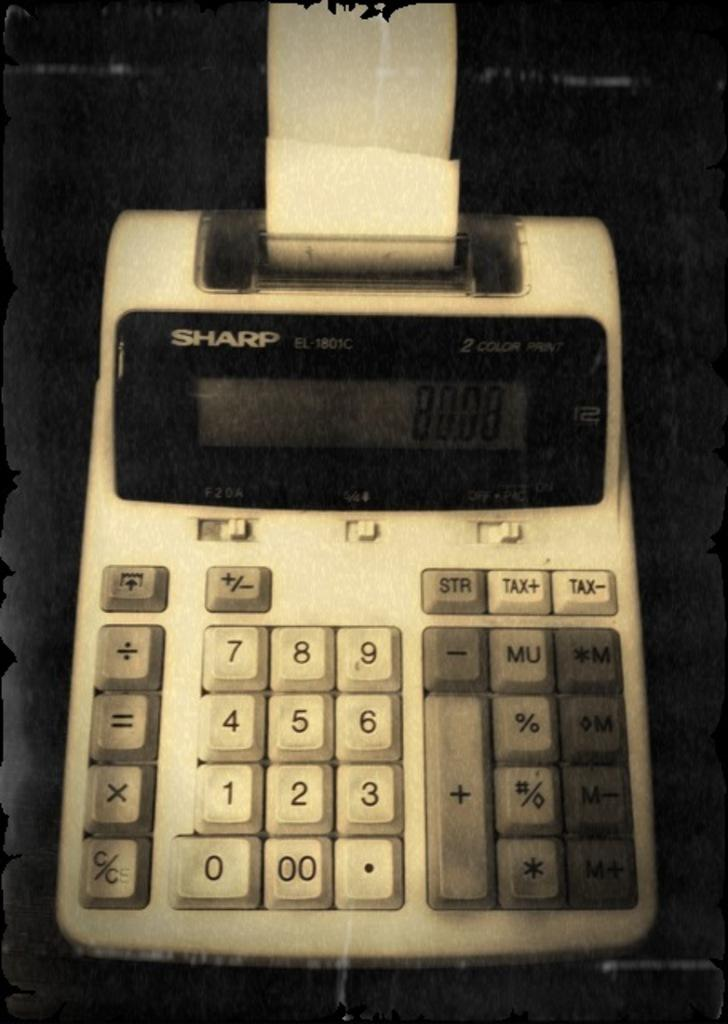<image>
Write a terse but informative summary of the picture. A Sharp brand printing calculator with paper in it. 